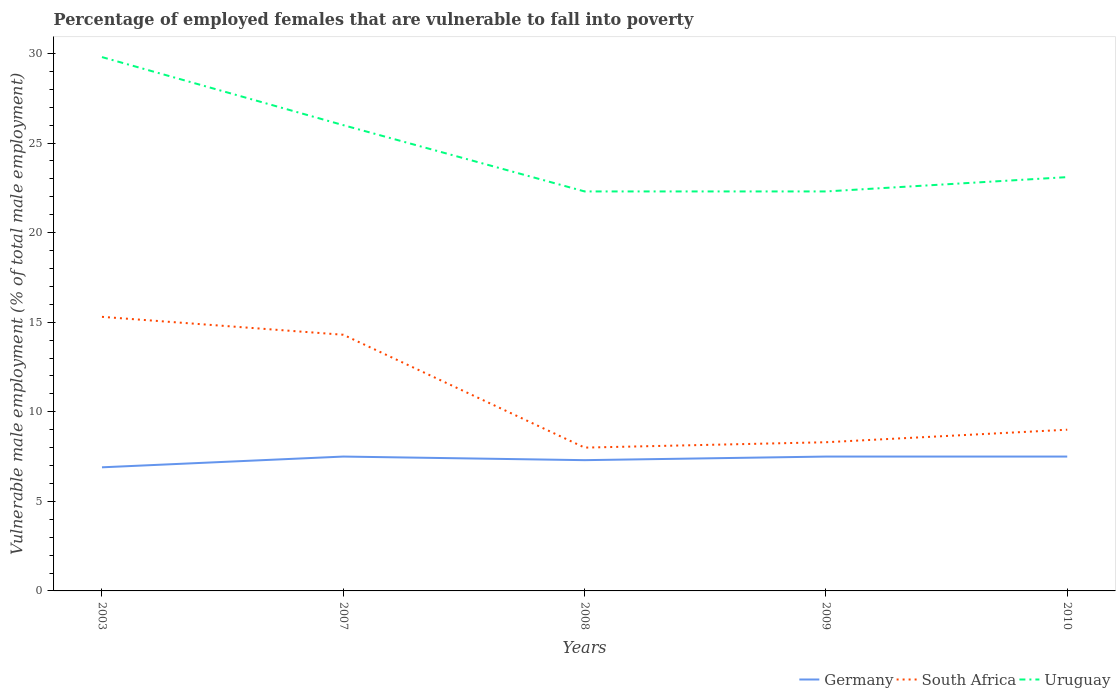Across all years, what is the maximum percentage of employed females who are vulnerable to fall into poverty in Germany?
Provide a short and direct response. 6.9. What is the total percentage of employed females who are vulnerable to fall into poverty in South Africa in the graph?
Provide a succinct answer. -0.7. What is the difference between the highest and the second highest percentage of employed females who are vulnerable to fall into poverty in Uruguay?
Your answer should be very brief. 7.5. What is the difference between the highest and the lowest percentage of employed females who are vulnerable to fall into poverty in South Africa?
Give a very brief answer. 2. Is the percentage of employed females who are vulnerable to fall into poverty in South Africa strictly greater than the percentage of employed females who are vulnerable to fall into poverty in Uruguay over the years?
Keep it short and to the point. Yes. How many years are there in the graph?
Make the answer very short. 5. Are the values on the major ticks of Y-axis written in scientific E-notation?
Offer a very short reply. No. Where does the legend appear in the graph?
Your answer should be very brief. Bottom right. What is the title of the graph?
Provide a short and direct response. Percentage of employed females that are vulnerable to fall into poverty. Does "East Asia (all income levels)" appear as one of the legend labels in the graph?
Provide a succinct answer. No. What is the label or title of the Y-axis?
Offer a terse response. Vulnerable male employment (% of total male employment). What is the Vulnerable male employment (% of total male employment) of Germany in 2003?
Your answer should be very brief. 6.9. What is the Vulnerable male employment (% of total male employment) in South Africa in 2003?
Ensure brevity in your answer.  15.3. What is the Vulnerable male employment (% of total male employment) in Uruguay in 2003?
Provide a succinct answer. 29.8. What is the Vulnerable male employment (% of total male employment) of Germany in 2007?
Ensure brevity in your answer.  7.5. What is the Vulnerable male employment (% of total male employment) of South Africa in 2007?
Your response must be concise. 14.3. What is the Vulnerable male employment (% of total male employment) of Uruguay in 2007?
Your response must be concise. 26. What is the Vulnerable male employment (% of total male employment) of Germany in 2008?
Keep it short and to the point. 7.3. What is the Vulnerable male employment (% of total male employment) of Uruguay in 2008?
Give a very brief answer. 22.3. What is the Vulnerable male employment (% of total male employment) of Germany in 2009?
Provide a short and direct response. 7.5. What is the Vulnerable male employment (% of total male employment) of South Africa in 2009?
Give a very brief answer. 8.3. What is the Vulnerable male employment (% of total male employment) of Uruguay in 2009?
Make the answer very short. 22.3. What is the Vulnerable male employment (% of total male employment) of Germany in 2010?
Your response must be concise. 7.5. What is the Vulnerable male employment (% of total male employment) in South Africa in 2010?
Ensure brevity in your answer.  9. What is the Vulnerable male employment (% of total male employment) of Uruguay in 2010?
Your response must be concise. 23.1. Across all years, what is the maximum Vulnerable male employment (% of total male employment) in Germany?
Offer a terse response. 7.5. Across all years, what is the maximum Vulnerable male employment (% of total male employment) in South Africa?
Your answer should be compact. 15.3. Across all years, what is the maximum Vulnerable male employment (% of total male employment) of Uruguay?
Ensure brevity in your answer.  29.8. Across all years, what is the minimum Vulnerable male employment (% of total male employment) in Germany?
Give a very brief answer. 6.9. Across all years, what is the minimum Vulnerable male employment (% of total male employment) in Uruguay?
Provide a succinct answer. 22.3. What is the total Vulnerable male employment (% of total male employment) of Germany in the graph?
Offer a terse response. 36.7. What is the total Vulnerable male employment (% of total male employment) of South Africa in the graph?
Your response must be concise. 54.9. What is the total Vulnerable male employment (% of total male employment) in Uruguay in the graph?
Ensure brevity in your answer.  123.5. What is the difference between the Vulnerable male employment (% of total male employment) of South Africa in 2003 and that in 2007?
Your answer should be compact. 1. What is the difference between the Vulnerable male employment (% of total male employment) of South Africa in 2003 and that in 2008?
Ensure brevity in your answer.  7.3. What is the difference between the Vulnerable male employment (% of total male employment) in Germany in 2003 and that in 2009?
Provide a succinct answer. -0.6. What is the difference between the Vulnerable male employment (% of total male employment) in South Africa in 2003 and that in 2009?
Make the answer very short. 7. What is the difference between the Vulnerable male employment (% of total male employment) in South Africa in 2003 and that in 2010?
Ensure brevity in your answer.  6.3. What is the difference between the Vulnerable male employment (% of total male employment) of Uruguay in 2003 and that in 2010?
Provide a short and direct response. 6.7. What is the difference between the Vulnerable male employment (% of total male employment) of Germany in 2007 and that in 2010?
Your response must be concise. 0. What is the difference between the Vulnerable male employment (% of total male employment) of Uruguay in 2007 and that in 2010?
Your answer should be very brief. 2.9. What is the difference between the Vulnerable male employment (% of total male employment) of South Africa in 2008 and that in 2009?
Your response must be concise. -0.3. What is the difference between the Vulnerable male employment (% of total male employment) in Uruguay in 2008 and that in 2009?
Your answer should be very brief. 0. What is the difference between the Vulnerable male employment (% of total male employment) in Germany in 2008 and that in 2010?
Your answer should be compact. -0.2. What is the difference between the Vulnerable male employment (% of total male employment) in Germany in 2009 and that in 2010?
Offer a very short reply. 0. What is the difference between the Vulnerable male employment (% of total male employment) of Germany in 2003 and the Vulnerable male employment (% of total male employment) of South Africa in 2007?
Offer a terse response. -7.4. What is the difference between the Vulnerable male employment (% of total male employment) of Germany in 2003 and the Vulnerable male employment (% of total male employment) of Uruguay in 2007?
Your response must be concise. -19.1. What is the difference between the Vulnerable male employment (% of total male employment) of Germany in 2003 and the Vulnerable male employment (% of total male employment) of South Africa in 2008?
Your answer should be compact. -1.1. What is the difference between the Vulnerable male employment (% of total male employment) of Germany in 2003 and the Vulnerable male employment (% of total male employment) of Uruguay in 2008?
Give a very brief answer. -15.4. What is the difference between the Vulnerable male employment (% of total male employment) of Germany in 2003 and the Vulnerable male employment (% of total male employment) of South Africa in 2009?
Your answer should be compact. -1.4. What is the difference between the Vulnerable male employment (% of total male employment) of Germany in 2003 and the Vulnerable male employment (% of total male employment) of Uruguay in 2009?
Ensure brevity in your answer.  -15.4. What is the difference between the Vulnerable male employment (% of total male employment) in South Africa in 2003 and the Vulnerable male employment (% of total male employment) in Uruguay in 2009?
Ensure brevity in your answer.  -7. What is the difference between the Vulnerable male employment (% of total male employment) of Germany in 2003 and the Vulnerable male employment (% of total male employment) of Uruguay in 2010?
Provide a succinct answer. -16.2. What is the difference between the Vulnerable male employment (% of total male employment) in Germany in 2007 and the Vulnerable male employment (% of total male employment) in Uruguay in 2008?
Your response must be concise. -14.8. What is the difference between the Vulnerable male employment (% of total male employment) in Germany in 2007 and the Vulnerable male employment (% of total male employment) in South Africa in 2009?
Provide a short and direct response. -0.8. What is the difference between the Vulnerable male employment (% of total male employment) in Germany in 2007 and the Vulnerable male employment (% of total male employment) in Uruguay in 2009?
Provide a short and direct response. -14.8. What is the difference between the Vulnerable male employment (% of total male employment) in Germany in 2007 and the Vulnerable male employment (% of total male employment) in South Africa in 2010?
Provide a succinct answer. -1.5. What is the difference between the Vulnerable male employment (% of total male employment) of Germany in 2007 and the Vulnerable male employment (% of total male employment) of Uruguay in 2010?
Provide a short and direct response. -15.6. What is the difference between the Vulnerable male employment (% of total male employment) of South Africa in 2007 and the Vulnerable male employment (% of total male employment) of Uruguay in 2010?
Make the answer very short. -8.8. What is the difference between the Vulnerable male employment (% of total male employment) in Germany in 2008 and the Vulnerable male employment (% of total male employment) in South Africa in 2009?
Your answer should be compact. -1. What is the difference between the Vulnerable male employment (% of total male employment) in South Africa in 2008 and the Vulnerable male employment (% of total male employment) in Uruguay in 2009?
Provide a short and direct response. -14.3. What is the difference between the Vulnerable male employment (% of total male employment) in Germany in 2008 and the Vulnerable male employment (% of total male employment) in South Africa in 2010?
Offer a terse response. -1.7. What is the difference between the Vulnerable male employment (% of total male employment) in Germany in 2008 and the Vulnerable male employment (% of total male employment) in Uruguay in 2010?
Keep it short and to the point. -15.8. What is the difference between the Vulnerable male employment (% of total male employment) in South Africa in 2008 and the Vulnerable male employment (% of total male employment) in Uruguay in 2010?
Make the answer very short. -15.1. What is the difference between the Vulnerable male employment (% of total male employment) in Germany in 2009 and the Vulnerable male employment (% of total male employment) in Uruguay in 2010?
Make the answer very short. -15.6. What is the difference between the Vulnerable male employment (% of total male employment) of South Africa in 2009 and the Vulnerable male employment (% of total male employment) of Uruguay in 2010?
Your answer should be compact. -14.8. What is the average Vulnerable male employment (% of total male employment) in Germany per year?
Offer a very short reply. 7.34. What is the average Vulnerable male employment (% of total male employment) in South Africa per year?
Ensure brevity in your answer.  10.98. What is the average Vulnerable male employment (% of total male employment) of Uruguay per year?
Make the answer very short. 24.7. In the year 2003, what is the difference between the Vulnerable male employment (% of total male employment) in Germany and Vulnerable male employment (% of total male employment) in South Africa?
Your response must be concise. -8.4. In the year 2003, what is the difference between the Vulnerable male employment (% of total male employment) of Germany and Vulnerable male employment (% of total male employment) of Uruguay?
Make the answer very short. -22.9. In the year 2003, what is the difference between the Vulnerable male employment (% of total male employment) in South Africa and Vulnerable male employment (% of total male employment) in Uruguay?
Ensure brevity in your answer.  -14.5. In the year 2007, what is the difference between the Vulnerable male employment (% of total male employment) of Germany and Vulnerable male employment (% of total male employment) of Uruguay?
Your answer should be very brief. -18.5. In the year 2007, what is the difference between the Vulnerable male employment (% of total male employment) in South Africa and Vulnerable male employment (% of total male employment) in Uruguay?
Keep it short and to the point. -11.7. In the year 2008, what is the difference between the Vulnerable male employment (% of total male employment) in Germany and Vulnerable male employment (% of total male employment) in South Africa?
Ensure brevity in your answer.  -0.7. In the year 2008, what is the difference between the Vulnerable male employment (% of total male employment) of Germany and Vulnerable male employment (% of total male employment) of Uruguay?
Ensure brevity in your answer.  -15. In the year 2008, what is the difference between the Vulnerable male employment (% of total male employment) in South Africa and Vulnerable male employment (% of total male employment) in Uruguay?
Provide a succinct answer. -14.3. In the year 2009, what is the difference between the Vulnerable male employment (% of total male employment) of Germany and Vulnerable male employment (% of total male employment) of South Africa?
Ensure brevity in your answer.  -0.8. In the year 2009, what is the difference between the Vulnerable male employment (% of total male employment) of Germany and Vulnerable male employment (% of total male employment) of Uruguay?
Provide a succinct answer. -14.8. In the year 2010, what is the difference between the Vulnerable male employment (% of total male employment) of Germany and Vulnerable male employment (% of total male employment) of South Africa?
Provide a short and direct response. -1.5. In the year 2010, what is the difference between the Vulnerable male employment (% of total male employment) in Germany and Vulnerable male employment (% of total male employment) in Uruguay?
Provide a succinct answer. -15.6. In the year 2010, what is the difference between the Vulnerable male employment (% of total male employment) of South Africa and Vulnerable male employment (% of total male employment) of Uruguay?
Make the answer very short. -14.1. What is the ratio of the Vulnerable male employment (% of total male employment) in South Africa in 2003 to that in 2007?
Provide a short and direct response. 1.07. What is the ratio of the Vulnerable male employment (% of total male employment) of Uruguay in 2003 to that in 2007?
Ensure brevity in your answer.  1.15. What is the ratio of the Vulnerable male employment (% of total male employment) of Germany in 2003 to that in 2008?
Provide a succinct answer. 0.95. What is the ratio of the Vulnerable male employment (% of total male employment) of South Africa in 2003 to that in 2008?
Make the answer very short. 1.91. What is the ratio of the Vulnerable male employment (% of total male employment) in Uruguay in 2003 to that in 2008?
Make the answer very short. 1.34. What is the ratio of the Vulnerable male employment (% of total male employment) of South Africa in 2003 to that in 2009?
Offer a very short reply. 1.84. What is the ratio of the Vulnerable male employment (% of total male employment) in Uruguay in 2003 to that in 2009?
Provide a succinct answer. 1.34. What is the ratio of the Vulnerable male employment (% of total male employment) in Germany in 2003 to that in 2010?
Make the answer very short. 0.92. What is the ratio of the Vulnerable male employment (% of total male employment) of Uruguay in 2003 to that in 2010?
Give a very brief answer. 1.29. What is the ratio of the Vulnerable male employment (% of total male employment) in Germany in 2007 to that in 2008?
Your response must be concise. 1.03. What is the ratio of the Vulnerable male employment (% of total male employment) in South Africa in 2007 to that in 2008?
Provide a succinct answer. 1.79. What is the ratio of the Vulnerable male employment (% of total male employment) in Uruguay in 2007 to that in 2008?
Give a very brief answer. 1.17. What is the ratio of the Vulnerable male employment (% of total male employment) in South Africa in 2007 to that in 2009?
Provide a short and direct response. 1.72. What is the ratio of the Vulnerable male employment (% of total male employment) in Uruguay in 2007 to that in 2009?
Your answer should be compact. 1.17. What is the ratio of the Vulnerable male employment (% of total male employment) in Germany in 2007 to that in 2010?
Your answer should be very brief. 1. What is the ratio of the Vulnerable male employment (% of total male employment) in South Africa in 2007 to that in 2010?
Ensure brevity in your answer.  1.59. What is the ratio of the Vulnerable male employment (% of total male employment) in Uruguay in 2007 to that in 2010?
Your answer should be very brief. 1.13. What is the ratio of the Vulnerable male employment (% of total male employment) in Germany in 2008 to that in 2009?
Ensure brevity in your answer.  0.97. What is the ratio of the Vulnerable male employment (% of total male employment) of South Africa in 2008 to that in 2009?
Ensure brevity in your answer.  0.96. What is the ratio of the Vulnerable male employment (% of total male employment) of Germany in 2008 to that in 2010?
Provide a short and direct response. 0.97. What is the ratio of the Vulnerable male employment (% of total male employment) of South Africa in 2008 to that in 2010?
Give a very brief answer. 0.89. What is the ratio of the Vulnerable male employment (% of total male employment) of Uruguay in 2008 to that in 2010?
Offer a terse response. 0.97. What is the ratio of the Vulnerable male employment (% of total male employment) of South Africa in 2009 to that in 2010?
Your answer should be very brief. 0.92. What is the ratio of the Vulnerable male employment (% of total male employment) of Uruguay in 2009 to that in 2010?
Provide a short and direct response. 0.97. What is the difference between the highest and the second highest Vulnerable male employment (% of total male employment) in Uruguay?
Offer a terse response. 3.8. What is the difference between the highest and the lowest Vulnerable male employment (% of total male employment) of South Africa?
Give a very brief answer. 7.3. What is the difference between the highest and the lowest Vulnerable male employment (% of total male employment) of Uruguay?
Your answer should be very brief. 7.5. 